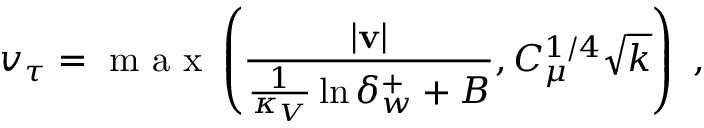Convert formula to latex. <formula><loc_0><loc_0><loc_500><loc_500>v _ { \tau } = m a x \left ( \frac { | v | } { \frac { 1 } { \kappa _ { V } } \ln { \delta _ { w } ^ { + } } + B } , C _ { \mu } ^ { 1 / 4 } \sqrt { k } \right ) ,</formula> 